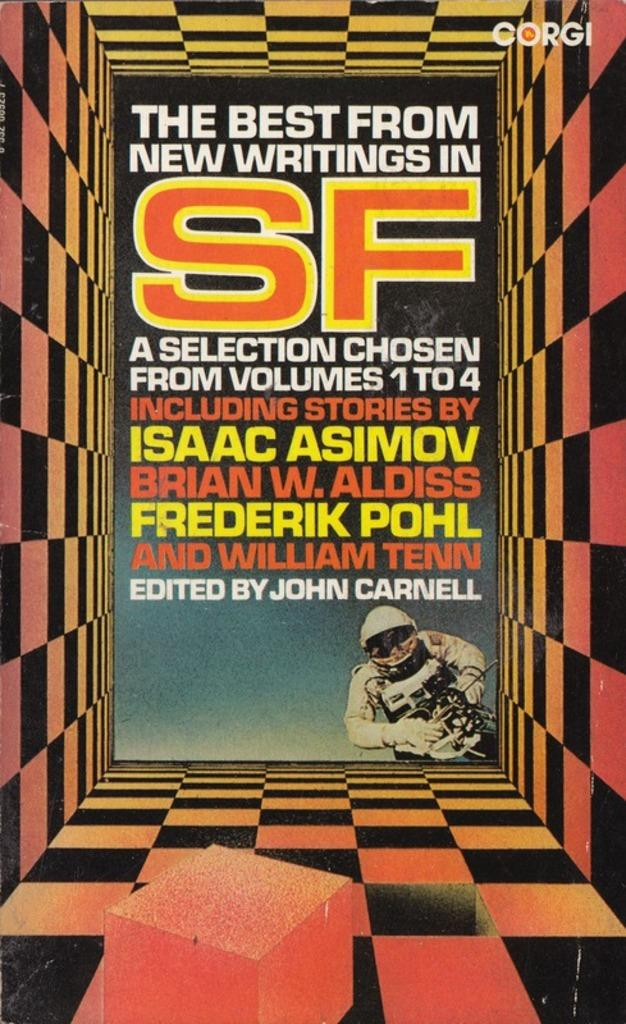<image>
Describe the image concisely. Colorful poster of a book titled The Best From New Writings in SF a selection of chosen from volumes 1 to 4 including stories edited by John Carnell 